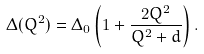<formula> <loc_0><loc_0><loc_500><loc_500>\Delta ( Q ^ { 2 } ) = \Delta _ { 0 } \left ( 1 + \frac { 2 Q ^ { 2 } } { Q ^ { 2 } + d } \right ) .</formula> 